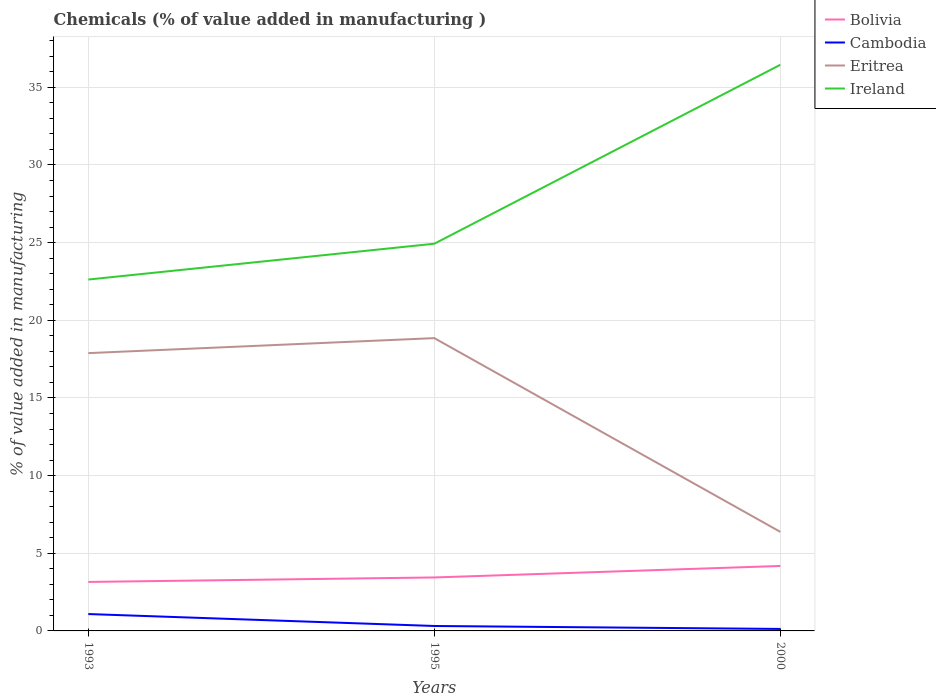Does the line corresponding to Eritrea intersect with the line corresponding to Cambodia?
Keep it short and to the point. No. Across all years, what is the maximum value added in manufacturing chemicals in Ireland?
Provide a succinct answer. 22.62. What is the total value added in manufacturing chemicals in Eritrea in the graph?
Make the answer very short. 12.47. What is the difference between the highest and the second highest value added in manufacturing chemicals in Ireland?
Make the answer very short. 13.83. What is the difference between the highest and the lowest value added in manufacturing chemicals in Bolivia?
Your answer should be very brief. 1. Is the value added in manufacturing chemicals in Cambodia strictly greater than the value added in manufacturing chemicals in Ireland over the years?
Your response must be concise. Yes. What is the title of the graph?
Offer a very short reply. Chemicals (% of value added in manufacturing ). What is the label or title of the Y-axis?
Offer a very short reply. % of value added in manufacturing. What is the % of value added in manufacturing in Bolivia in 1993?
Keep it short and to the point. 3.15. What is the % of value added in manufacturing of Cambodia in 1993?
Ensure brevity in your answer.  1.09. What is the % of value added in manufacturing of Eritrea in 1993?
Ensure brevity in your answer.  17.89. What is the % of value added in manufacturing of Ireland in 1993?
Provide a succinct answer. 22.62. What is the % of value added in manufacturing in Bolivia in 1995?
Keep it short and to the point. 3.44. What is the % of value added in manufacturing in Cambodia in 1995?
Provide a short and direct response. 0.32. What is the % of value added in manufacturing of Eritrea in 1995?
Your answer should be compact. 18.85. What is the % of value added in manufacturing in Ireland in 1995?
Provide a short and direct response. 24.93. What is the % of value added in manufacturing of Bolivia in 2000?
Your answer should be very brief. 4.18. What is the % of value added in manufacturing of Cambodia in 2000?
Your answer should be very brief. 0.13. What is the % of value added in manufacturing of Eritrea in 2000?
Offer a very short reply. 6.38. What is the % of value added in manufacturing of Ireland in 2000?
Keep it short and to the point. 36.45. Across all years, what is the maximum % of value added in manufacturing of Bolivia?
Your answer should be compact. 4.18. Across all years, what is the maximum % of value added in manufacturing in Cambodia?
Your answer should be very brief. 1.09. Across all years, what is the maximum % of value added in manufacturing of Eritrea?
Your response must be concise. 18.85. Across all years, what is the maximum % of value added in manufacturing in Ireland?
Provide a short and direct response. 36.45. Across all years, what is the minimum % of value added in manufacturing of Bolivia?
Ensure brevity in your answer.  3.15. Across all years, what is the minimum % of value added in manufacturing of Cambodia?
Offer a terse response. 0.13. Across all years, what is the minimum % of value added in manufacturing in Eritrea?
Provide a succinct answer. 6.38. Across all years, what is the minimum % of value added in manufacturing of Ireland?
Give a very brief answer. 22.62. What is the total % of value added in manufacturing in Bolivia in the graph?
Offer a terse response. 10.78. What is the total % of value added in manufacturing of Cambodia in the graph?
Your response must be concise. 1.53. What is the total % of value added in manufacturing in Eritrea in the graph?
Provide a succinct answer. 43.12. What is the total % of value added in manufacturing in Ireland in the graph?
Make the answer very short. 84.01. What is the difference between the % of value added in manufacturing in Bolivia in 1993 and that in 1995?
Your answer should be compact. -0.29. What is the difference between the % of value added in manufacturing of Cambodia in 1993 and that in 1995?
Provide a short and direct response. 0.77. What is the difference between the % of value added in manufacturing in Eritrea in 1993 and that in 1995?
Offer a terse response. -0.97. What is the difference between the % of value added in manufacturing in Ireland in 1993 and that in 1995?
Offer a terse response. -2.31. What is the difference between the % of value added in manufacturing of Bolivia in 1993 and that in 2000?
Provide a short and direct response. -1.03. What is the difference between the % of value added in manufacturing of Eritrea in 1993 and that in 2000?
Keep it short and to the point. 11.51. What is the difference between the % of value added in manufacturing in Ireland in 1993 and that in 2000?
Keep it short and to the point. -13.83. What is the difference between the % of value added in manufacturing of Bolivia in 1995 and that in 2000?
Make the answer very short. -0.74. What is the difference between the % of value added in manufacturing in Cambodia in 1995 and that in 2000?
Your answer should be very brief. 0.19. What is the difference between the % of value added in manufacturing in Eritrea in 1995 and that in 2000?
Offer a terse response. 12.47. What is the difference between the % of value added in manufacturing of Ireland in 1995 and that in 2000?
Ensure brevity in your answer.  -11.52. What is the difference between the % of value added in manufacturing in Bolivia in 1993 and the % of value added in manufacturing in Cambodia in 1995?
Your answer should be compact. 2.84. What is the difference between the % of value added in manufacturing in Bolivia in 1993 and the % of value added in manufacturing in Eritrea in 1995?
Provide a succinct answer. -15.7. What is the difference between the % of value added in manufacturing of Bolivia in 1993 and the % of value added in manufacturing of Ireland in 1995?
Your answer should be very brief. -21.78. What is the difference between the % of value added in manufacturing of Cambodia in 1993 and the % of value added in manufacturing of Eritrea in 1995?
Provide a succinct answer. -17.77. What is the difference between the % of value added in manufacturing of Cambodia in 1993 and the % of value added in manufacturing of Ireland in 1995?
Offer a very short reply. -23.84. What is the difference between the % of value added in manufacturing of Eritrea in 1993 and the % of value added in manufacturing of Ireland in 1995?
Keep it short and to the point. -7.04. What is the difference between the % of value added in manufacturing of Bolivia in 1993 and the % of value added in manufacturing of Cambodia in 2000?
Your answer should be very brief. 3.03. What is the difference between the % of value added in manufacturing in Bolivia in 1993 and the % of value added in manufacturing in Eritrea in 2000?
Offer a very short reply. -3.22. What is the difference between the % of value added in manufacturing in Bolivia in 1993 and the % of value added in manufacturing in Ireland in 2000?
Provide a succinct answer. -33.3. What is the difference between the % of value added in manufacturing of Cambodia in 1993 and the % of value added in manufacturing of Eritrea in 2000?
Your answer should be compact. -5.29. What is the difference between the % of value added in manufacturing in Cambodia in 1993 and the % of value added in manufacturing in Ireland in 2000?
Give a very brief answer. -35.37. What is the difference between the % of value added in manufacturing of Eritrea in 1993 and the % of value added in manufacturing of Ireland in 2000?
Offer a very short reply. -18.56. What is the difference between the % of value added in manufacturing in Bolivia in 1995 and the % of value added in manufacturing in Cambodia in 2000?
Your response must be concise. 3.31. What is the difference between the % of value added in manufacturing in Bolivia in 1995 and the % of value added in manufacturing in Eritrea in 2000?
Offer a very short reply. -2.93. What is the difference between the % of value added in manufacturing in Bolivia in 1995 and the % of value added in manufacturing in Ireland in 2000?
Provide a short and direct response. -33.01. What is the difference between the % of value added in manufacturing of Cambodia in 1995 and the % of value added in manufacturing of Eritrea in 2000?
Offer a terse response. -6.06. What is the difference between the % of value added in manufacturing of Cambodia in 1995 and the % of value added in manufacturing of Ireland in 2000?
Your response must be concise. -36.13. What is the difference between the % of value added in manufacturing in Eritrea in 1995 and the % of value added in manufacturing in Ireland in 2000?
Your answer should be very brief. -17.6. What is the average % of value added in manufacturing in Bolivia per year?
Your answer should be very brief. 3.59. What is the average % of value added in manufacturing of Cambodia per year?
Make the answer very short. 0.51. What is the average % of value added in manufacturing of Eritrea per year?
Your answer should be compact. 14.37. What is the average % of value added in manufacturing in Ireland per year?
Ensure brevity in your answer.  28. In the year 1993, what is the difference between the % of value added in manufacturing of Bolivia and % of value added in manufacturing of Cambodia?
Make the answer very short. 2.07. In the year 1993, what is the difference between the % of value added in manufacturing of Bolivia and % of value added in manufacturing of Eritrea?
Provide a succinct answer. -14.73. In the year 1993, what is the difference between the % of value added in manufacturing of Bolivia and % of value added in manufacturing of Ireland?
Provide a succinct answer. -19.47. In the year 1993, what is the difference between the % of value added in manufacturing in Cambodia and % of value added in manufacturing in Eritrea?
Provide a succinct answer. -16.8. In the year 1993, what is the difference between the % of value added in manufacturing in Cambodia and % of value added in manufacturing in Ireland?
Your response must be concise. -21.54. In the year 1993, what is the difference between the % of value added in manufacturing of Eritrea and % of value added in manufacturing of Ireland?
Offer a very short reply. -4.74. In the year 1995, what is the difference between the % of value added in manufacturing in Bolivia and % of value added in manufacturing in Cambodia?
Provide a short and direct response. 3.12. In the year 1995, what is the difference between the % of value added in manufacturing in Bolivia and % of value added in manufacturing in Eritrea?
Keep it short and to the point. -15.41. In the year 1995, what is the difference between the % of value added in manufacturing in Bolivia and % of value added in manufacturing in Ireland?
Offer a terse response. -21.49. In the year 1995, what is the difference between the % of value added in manufacturing in Cambodia and % of value added in manufacturing in Eritrea?
Ensure brevity in your answer.  -18.53. In the year 1995, what is the difference between the % of value added in manufacturing in Cambodia and % of value added in manufacturing in Ireland?
Provide a succinct answer. -24.61. In the year 1995, what is the difference between the % of value added in manufacturing of Eritrea and % of value added in manufacturing of Ireland?
Provide a succinct answer. -6.08. In the year 2000, what is the difference between the % of value added in manufacturing of Bolivia and % of value added in manufacturing of Cambodia?
Make the answer very short. 4.05. In the year 2000, what is the difference between the % of value added in manufacturing in Bolivia and % of value added in manufacturing in Eritrea?
Your answer should be very brief. -2.2. In the year 2000, what is the difference between the % of value added in manufacturing in Bolivia and % of value added in manufacturing in Ireland?
Keep it short and to the point. -32.27. In the year 2000, what is the difference between the % of value added in manufacturing in Cambodia and % of value added in manufacturing in Eritrea?
Your response must be concise. -6.25. In the year 2000, what is the difference between the % of value added in manufacturing in Cambodia and % of value added in manufacturing in Ireland?
Provide a succinct answer. -36.32. In the year 2000, what is the difference between the % of value added in manufacturing of Eritrea and % of value added in manufacturing of Ireland?
Your answer should be very brief. -30.07. What is the ratio of the % of value added in manufacturing of Bolivia in 1993 to that in 1995?
Keep it short and to the point. 0.92. What is the ratio of the % of value added in manufacturing of Cambodia in 1993 to that in 1995?
Keep it short and to the point. 3.42. What is the ratio of the % of value added in manufacturing of Eritrea in 1993 to that in 1995?
Keep it short and to the point. 0.95. What is the ratio of the % of value added in manufacturing in Ireland in 1993 to that in 1995?
Offer a terse response. 0.91. What is the ratio of the % of value added in manufacturing of Bolivia in 1993 to that in 2000?
Provide a succinct answer. 0.75. What is the ratio of the % of value added in manufacturing in Cambodia in 1993 to that in 2000?
Keep it short and to the point. 8.49. What is the ratio of the % of value added in manufacturing in Eritrea in 1993 to that in 2000?
Keep it short and to the point. 2.8. What is the ratio of the % of value added in manufacturing of Ireland in 1993 to that in 2000?
Your answer should be compact. 0.62. What is the ratio of the % of value added in manufacturing of Bolivia in 1995 to that in 2000?
Provide a succinct answer. 0.82. What is the ratio of the % of value added in manufacturing of Cambodia in 1995 to that in 2000?
Keep it short and to the point. 2.48. What is the ratio of the % of value added in manufacturing of Eritrea in 1995 to that in 2000?
Make the answer very short. 2.96. What is the ratio of the % of value added in manufacturing of Ireland in 1995 to that in 2000?
Make the answer very short. 0.68. What is the difference between the highest and the second highest % of value added in manufacturing in Bolivia?
Make the answer very short. 0.74. What is the difference between the highest and the second highest % of value added in manufacturing of Cambodia?
Make the answer very short. 0.77. What is the difference between the highest and the second highest % of value added in manufacturing in Eritrea?
Offer a terse response. 0.97. What is the difference between the highest and the second highest % of value added in manufacturing in Ireland?
Provide a short and direct response. 11.52. What is the difference between the highest and the lowest % of value added in manufacturing of Bolivia?
Your answer should be compact. 1.03. What is the difference between the highest and the lowest % of value added in manufacturing of Cambodia?
Provide a short and direct response. 0.96. What is the difference between the highest and the lowest % of value added in manufacturing in Eritrea?
Your answer should be compact. 12.47. What is the difference between the highest and the lowest % of value added in manufacturing of Ireland?
Offer a terse response. 13.83. 